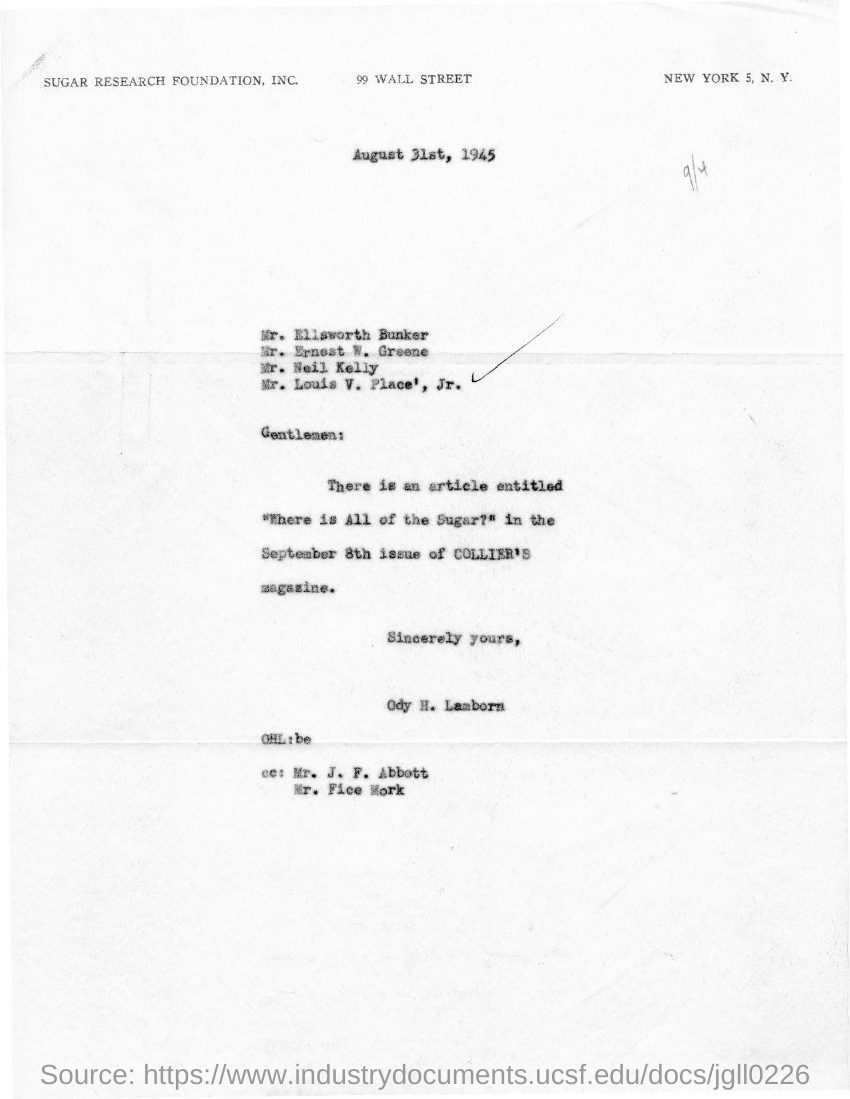List a handful of essential elements in this visual. The letter is dated August 31st, 1945. The letter is from Ody H. Lamborn. 